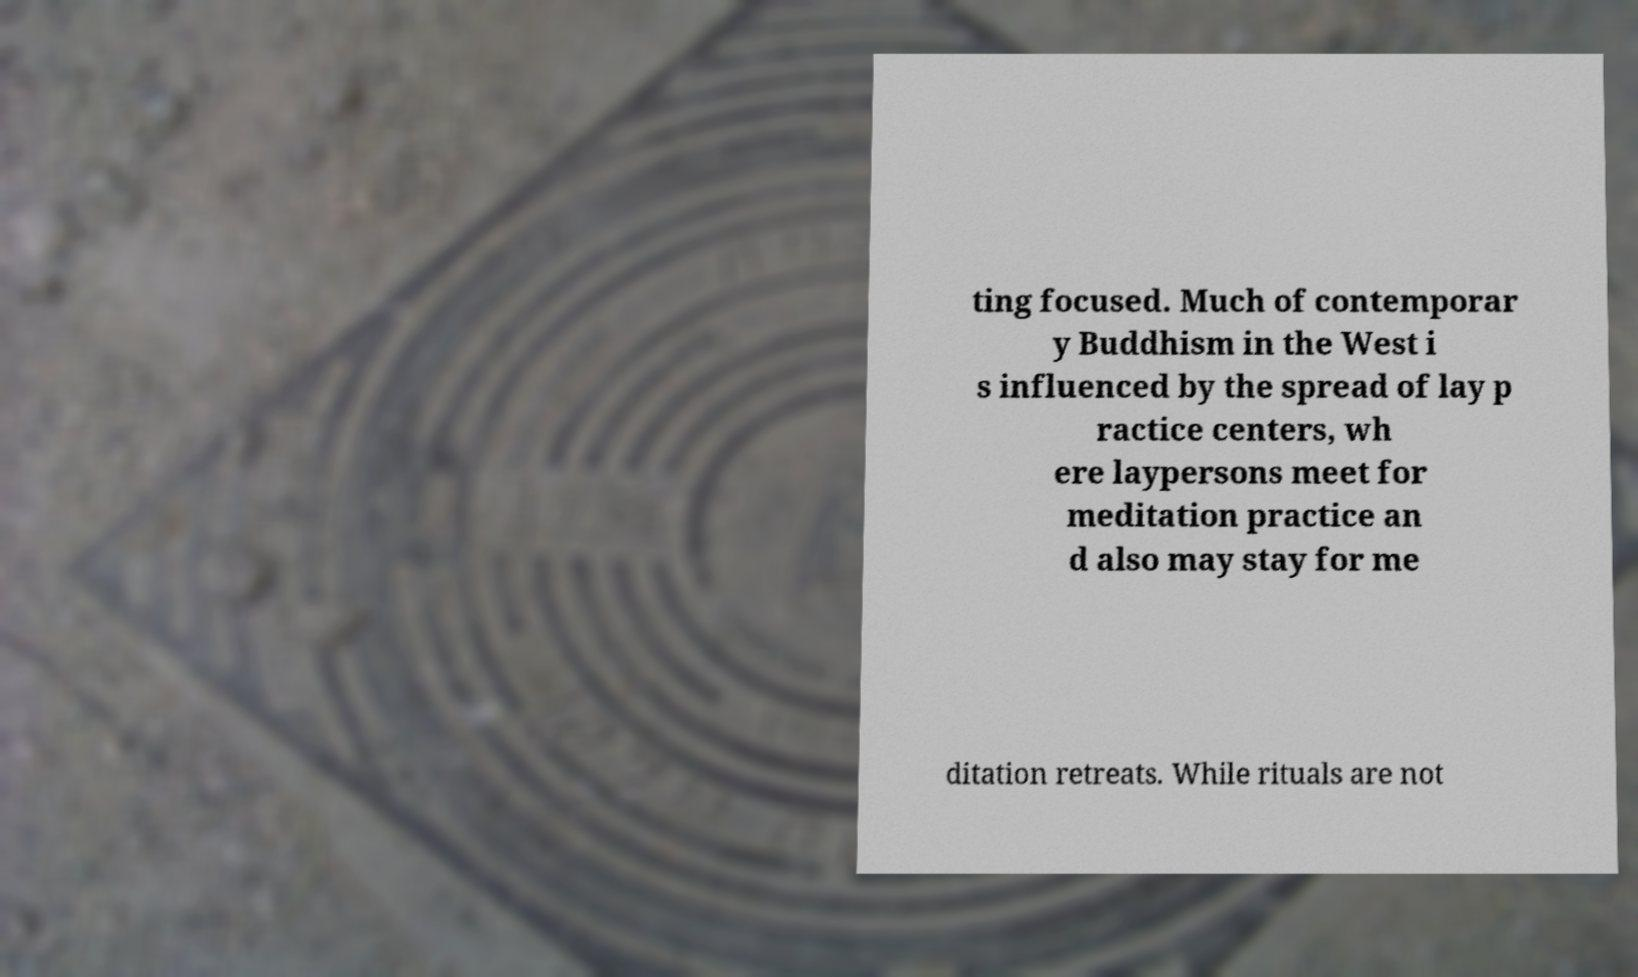Could you extract and type out the text from this image? ting focused. Much of contemporar y Buddhism in the West i s influenced by the spread of lay p ractice centers, wh ere laypersons meet for meditation practice an d also may stay for me ditation retreats. While rituals are not 